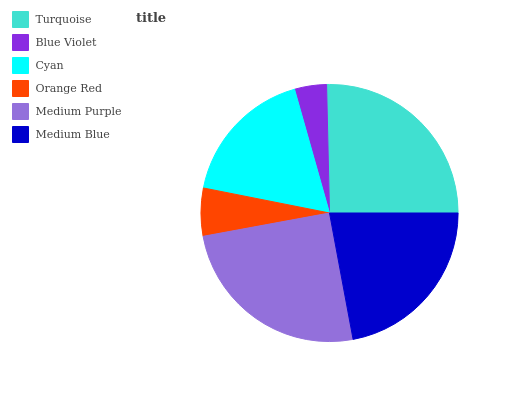Is Blue Violet the minimum?
Answer yes or no. Yes. Is Turquoise the maximum?
Answer yes or no. Yes. Is Cyan the minimum?
Answer yes or no. No. Is Cyan the maximum?
Answer yes or no. No. Is Cyan greater than Blue Violet?
Answer yes or no. Yes. Is Blue Violet less than Cyan?
Answer yes or no. Yes. Is Blue Violet greater than Cyan?
Answer yes or no. No. Is Cyan less than Blue Violet?
Answer yes or no. No. Is Medium Blue the high median?
Answer yes or no. Yes. Is Cyan the low median?
Answer yes or no. Yes. Is Turquoise the high median?
Answer yes or no. No. Is Medium Purple the low median?
Answer yes or no. No. 